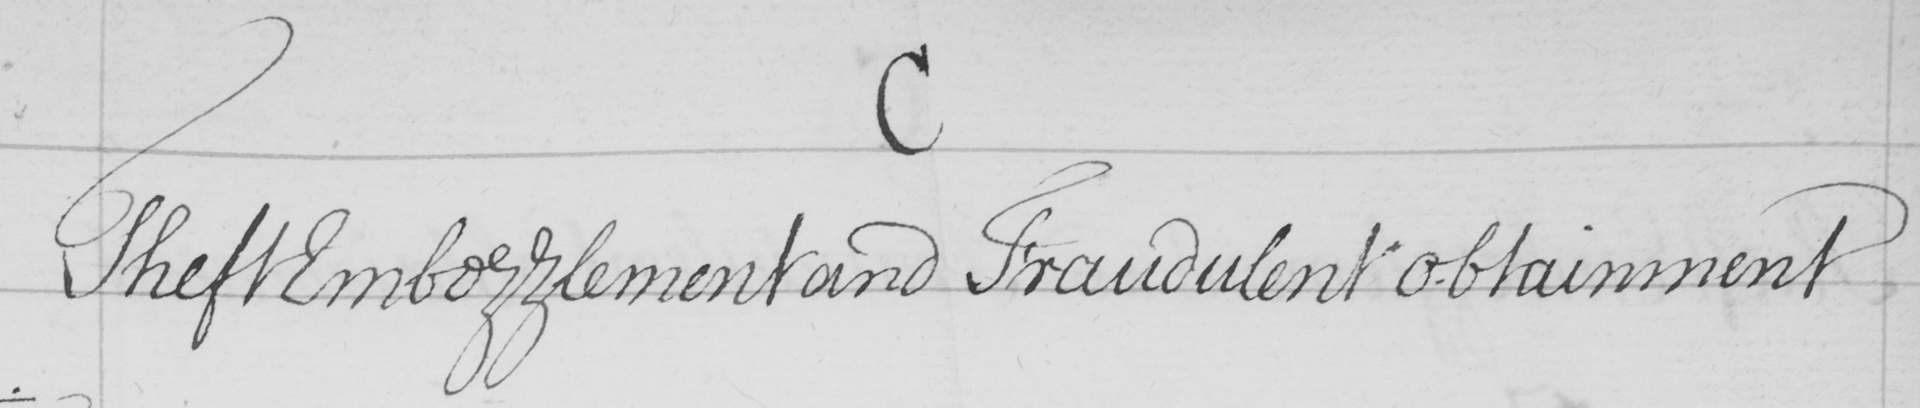Can you tell me what this handwritten text says? Theft Embezzlement and Fraudulent Obtainment 